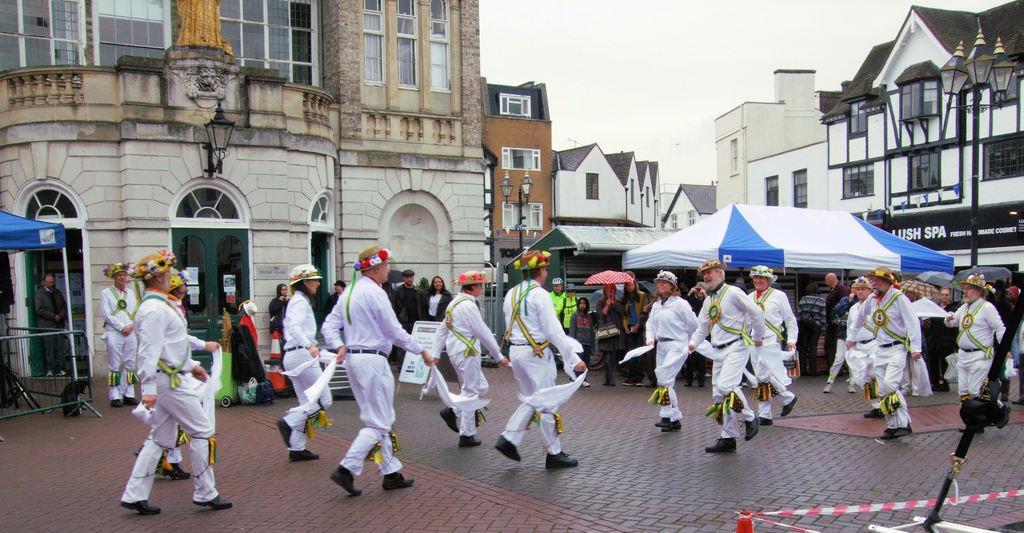Describe this image in one or two sentences. In the foreground of the picture I can see a group of people dancing on the floor. I can see a few of people standing on the side of the road and they are watching the dance performance. In the background, I can see the buildings and glass windows. I can see the tents on the road. I can see the decorative light poles on the top right side of the picture. 